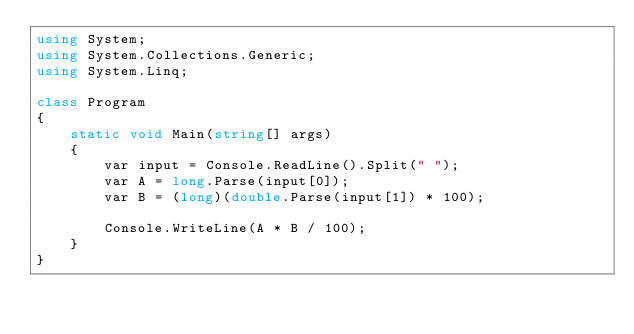<code> <loc_0><loc_0><loc_500><loc_500><_C#_>using System;
using System.Collections.Generic;
using System.Linq;

class Program
{
    static void Main(string[] args)
    {
        var input = Console.ReadLine().Split(" ");
        var A = long.Parse(input[0]);
        var B = (long)(double.Parse(input[1]) * 100);

        Console.WriteLine(A * B / 100);
    }
}
</code> 